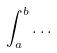Convert formula to latex. <formula><loc_0><loc_0><loc_500><loc_500>\int _ { a } ^ { b } \dots</formula> 